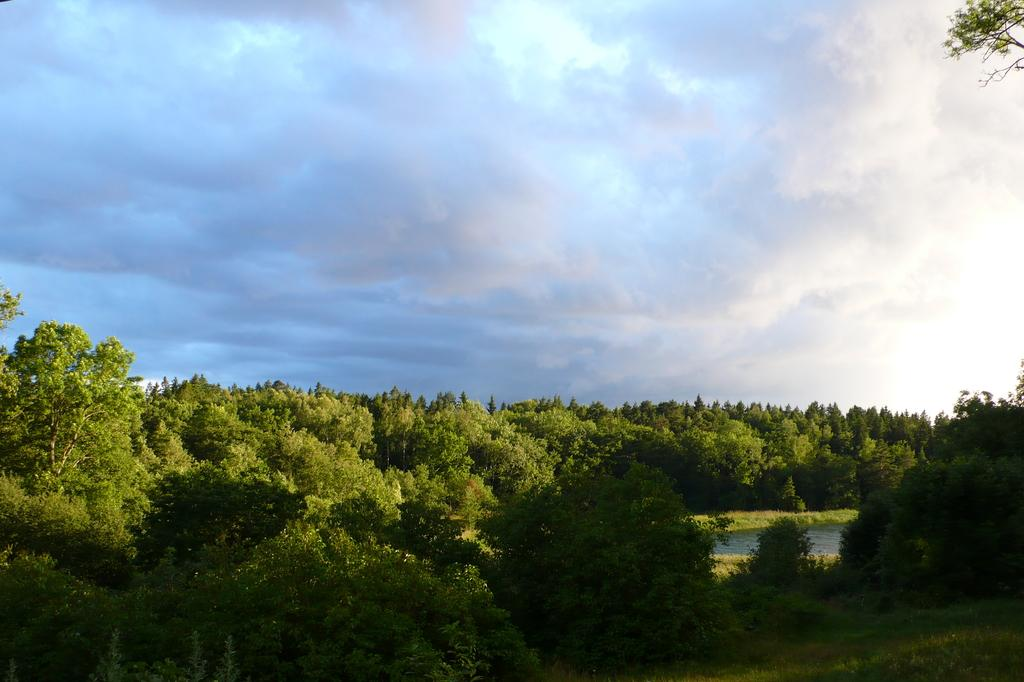What is located in the center of the image? There are trees in the center of the image. What is the condition of the sky in the image? The sky is cloudy in the image. What type of meal is being prepared in the image? There is no meal preparation visible in the image; it only features trees and a cloudy sky. How many eyes can be seen in the image? There are no eyes present in the image. 